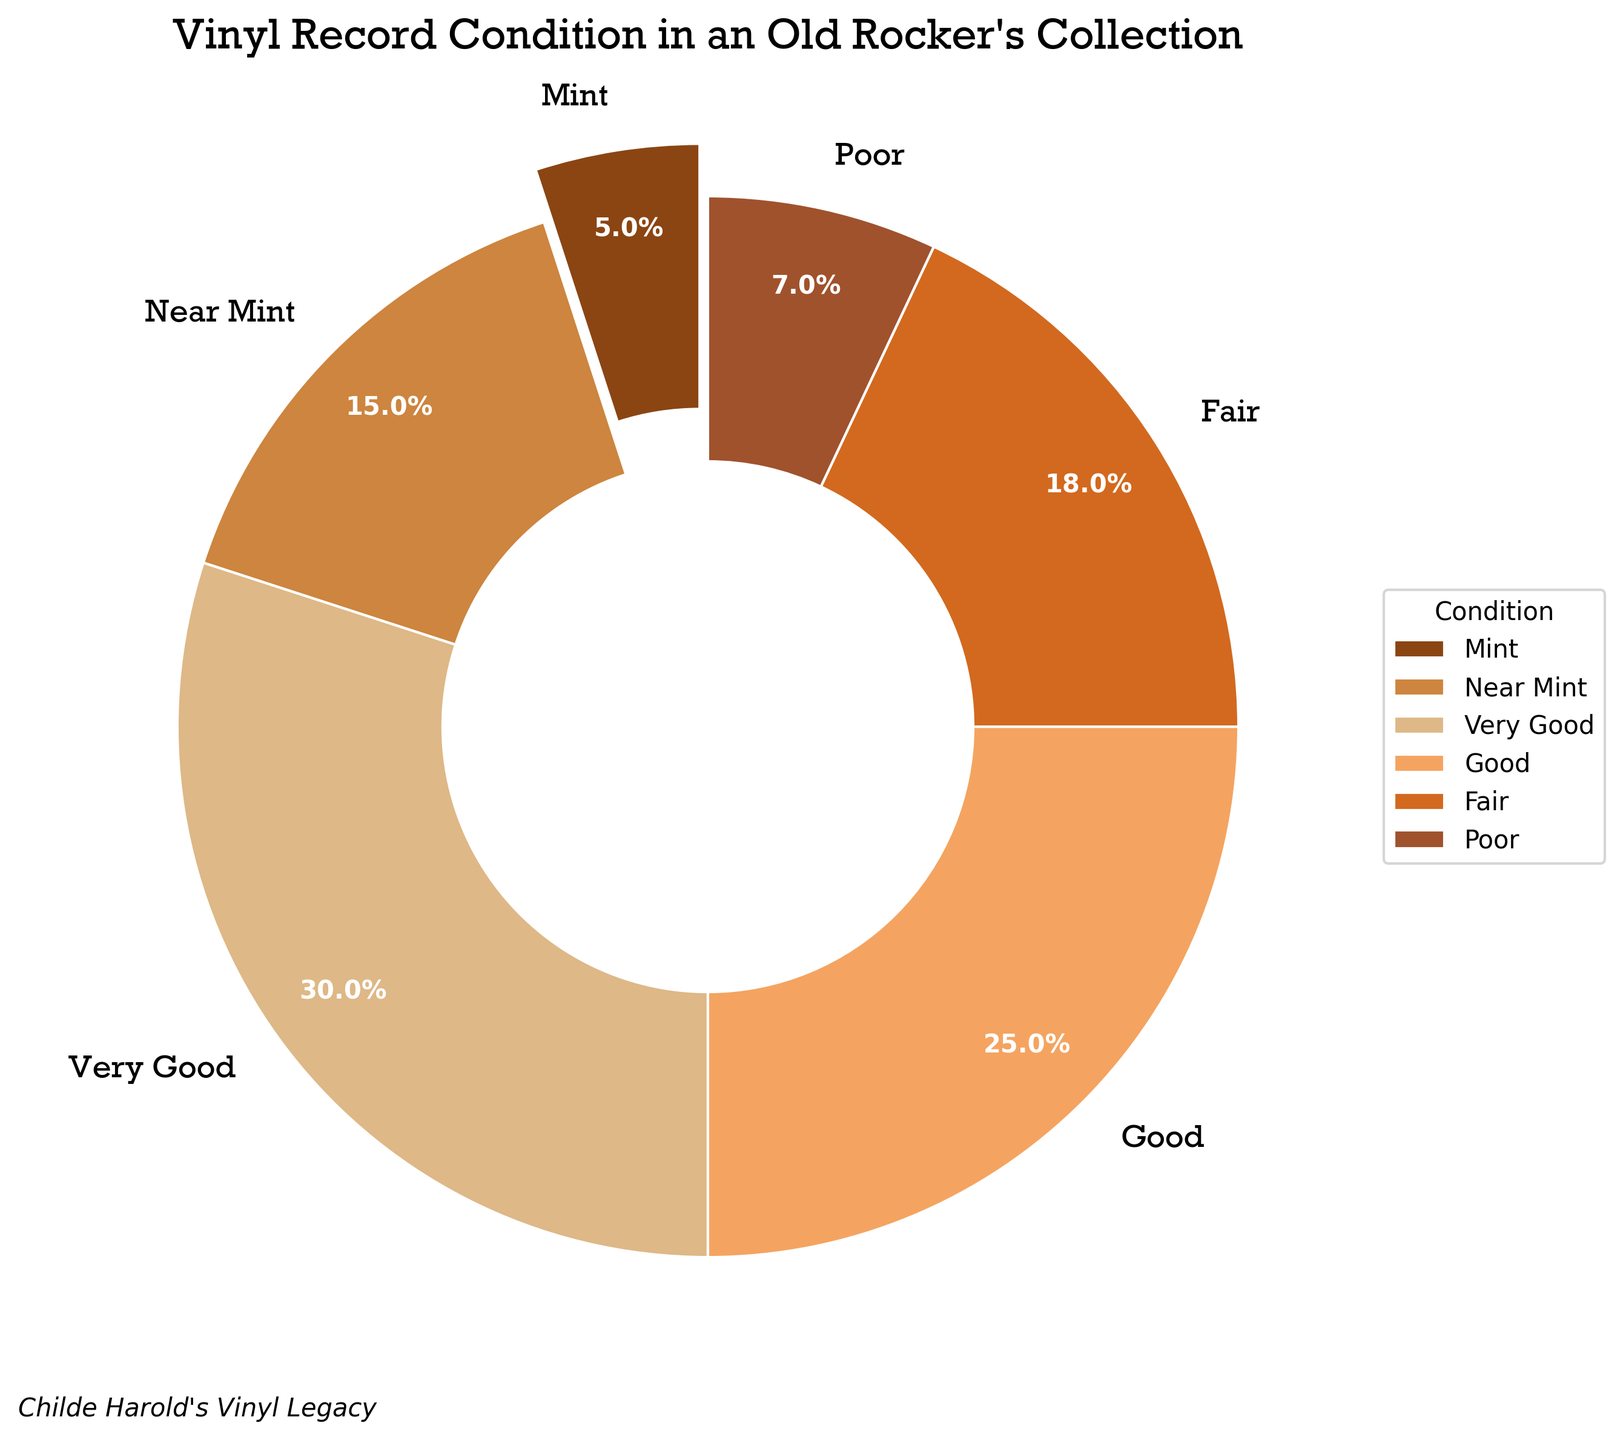Which condition has the highest percentage of records? To find the condition with the highest percentage, look at the label with the largest wedge in the pie chart. The "Very Good" segment covers the most area.
Answer: Very Good What is the combined percentage of records in Good and Fair condition? Add the percentages of the records in Good and Fair condition: Good (25%) + Fair (18%) = 43%.
Answer: 43% How many conditions have a percentage greater than or equal to 15%? Identify conditions with percentages of at least 15%. These are Near Mint (15%), Very Good (30%), and Good (25%). There are three such conditions.
Answer: 3 Which condition has the smallest percentage of records? Find the condition with the smallest wedge in the pie chart. The "Mint" segment is the smallest with 5%.
Answer: Mint Which wedge in the pie chart is exploded? Look for the wedge visually separated from the rest of the pie. The "Mint" wedge is exploded from the rest.
Answer: Mint Are there more records in Poor condition or Mint condition? Compare the percentages of Poor (7%) and Mint (5%) conditions. Poor has a higher percentage than Mint.
Answer: Poor What is the total percentage of records in less than Very Good condition (Good, Fair, Poor)? Add the percentages of records in conditions less than Very Good: Good (25%) + Fair (18%) + Poor (7%) = 50%.
Answer: 50% Which condition is represented by the second largest wedge? After identifying "Very Good" as the largest wedge, look for the second largest. Near Mint (15%) is the next largest segment.
Answer: Near Mint What are the colors used for Mint and Poor conditions? Identify the colors associated with each condition in the pie chart. Mint is represented by a brown color and Poor by a reddish-brown color.
Answer: Brown and Reddish-brown Which condition has a percentage that is the sum of Mint and Poor condition percentages? Add the percentages of Mint (5%) and Poor (7%): 5% + 7% = 12%. No condition directly has this percentage.
Answer: None 